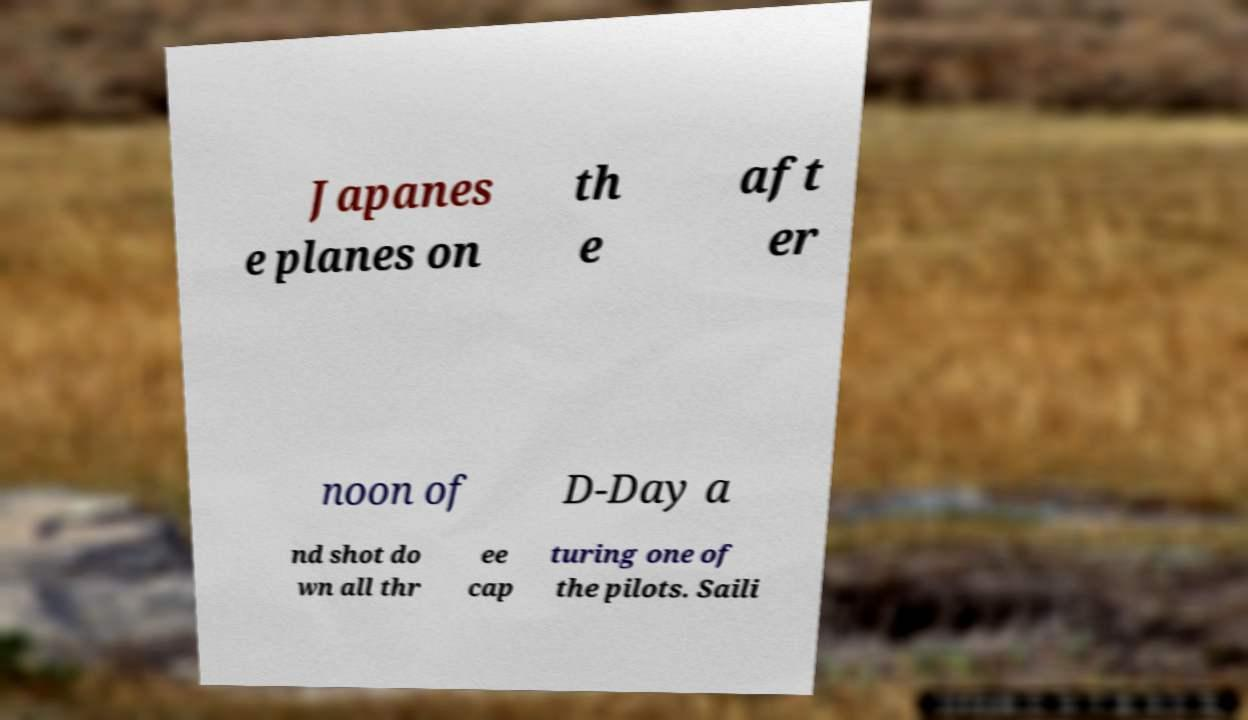I need the written content from this picture converted into text. Can you do that? Japanes e planes on th e aft er noon of D-Day a nd shot do wn all thr ee cap turing one of the pilots. Saili 